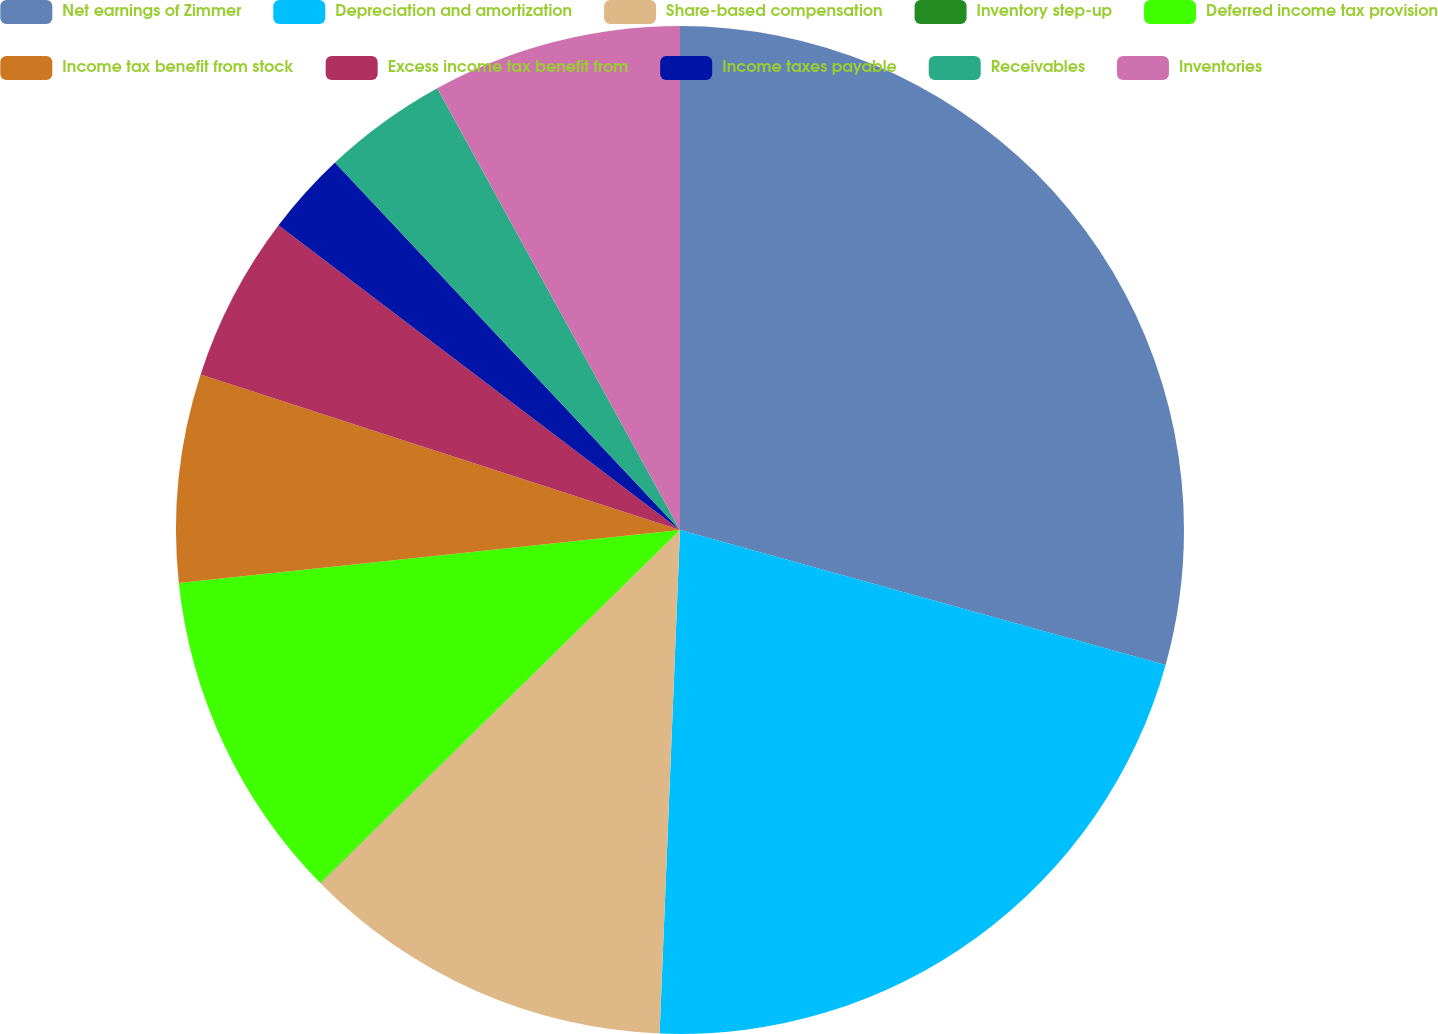<chart> <loc_0><loc_0><loc_500><loc_500><pie_chart><fcel>Net earnings of Zimmer<fcel>Depreciation and amortization<fcel>Share-based compensation<fcel>Inventory step-up<fcel>Deferred income tax provision<fcel>Income tax benefit from stock<fcel>Excess income tax benefit from<fcel>Income taxes payable<fcel>Receivables<fcel>Inventories<nl><fcel>29.32%<fcel>21.33%<fcel>12.0%<fcel>0.01%<fcel>10.67%<fcel>6.67%<fcel>5.34%<fcel>2.67%<fcel>4.0%<fcel>8.0%<nl></chart> 